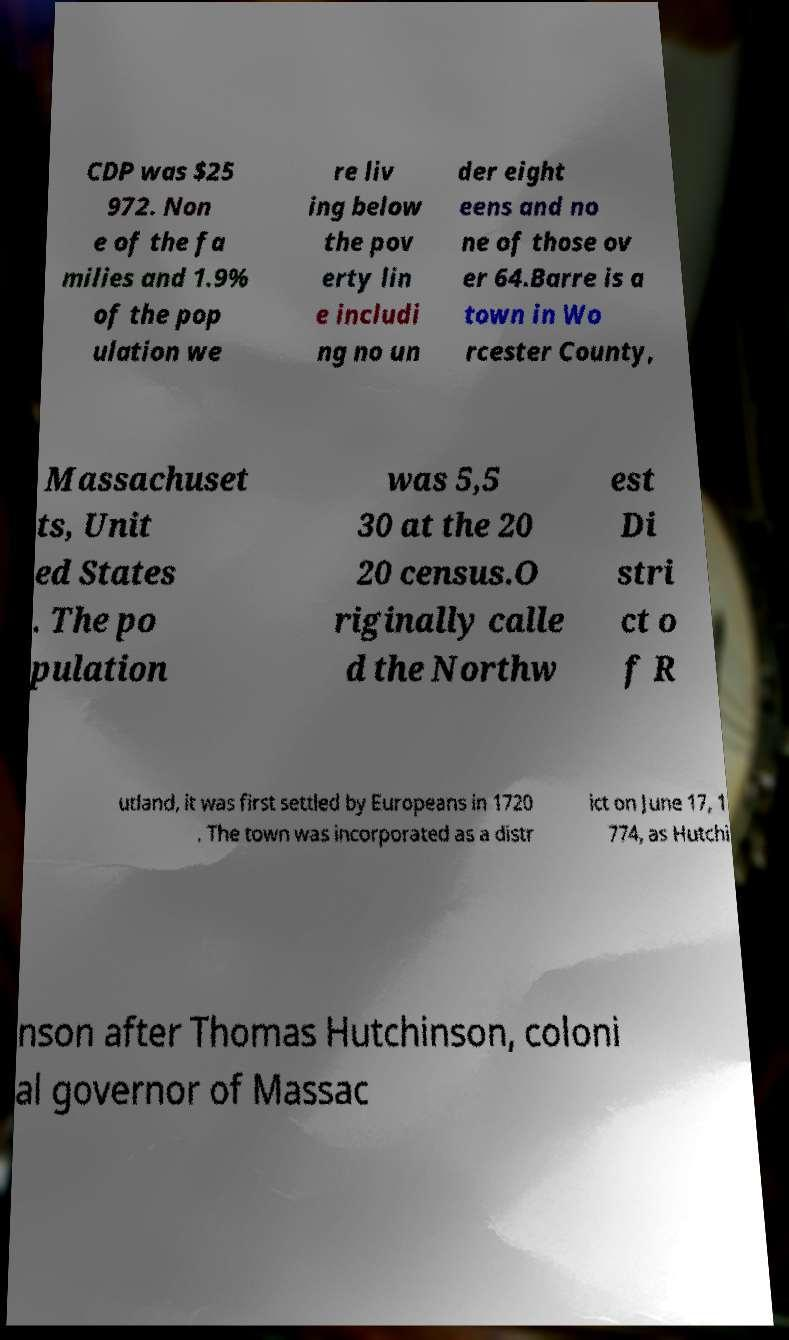What messages or text are displayed in this image? I need them in a readable, typed format. CDP was $25 972. Non e of the fa milies and 1.9% of the pop ulation we re liv ing below the pov erty lin e includi ng no un der eight eens and no ne of those ov er 64.Barre is a town in Wo rcester County, Massachuset ts, Unit ed States . The po pulation was 5,5 30 at the 20 20 census.O riginally calle d the Northw est Di stri ct o f R utland, it was first settled by Europeans in 1720 . The town was incorporated as a distr ict on June 17, 1 774, as Hutchi nson after Thomas Hutchinson, coloni al governor of Massac 